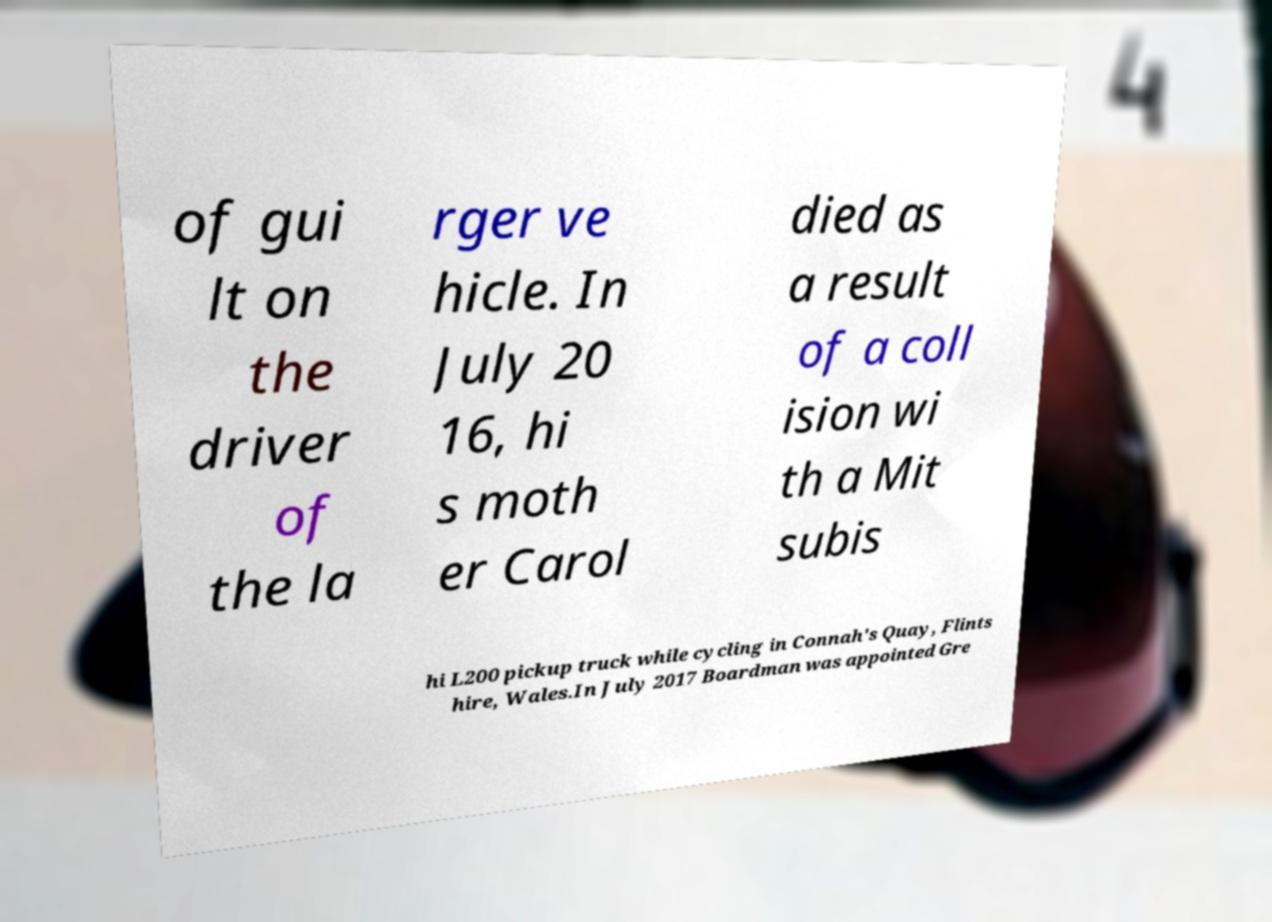Could you extract and type out the text from this image? of gui lt on the driver of the la rger ve hicle. In July 20 16, hi s moth er Carol died as a result of a coll ision wi th a Mit subis hi L200 pickup truck while cycling in Connah's Quay, Flints hire, Wales.In July 2017 Boardman was appointed Gre 